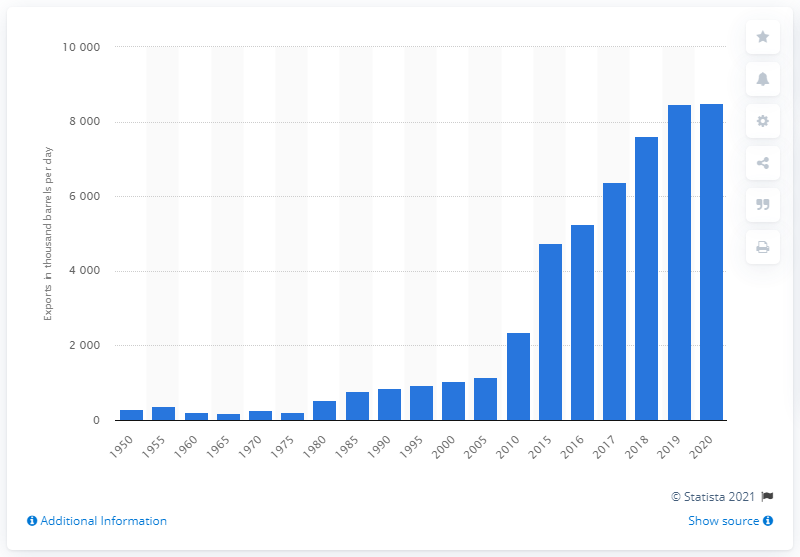Point out several critical features in this image. In 2020, the volume of petroleum products exported reached its peak. 